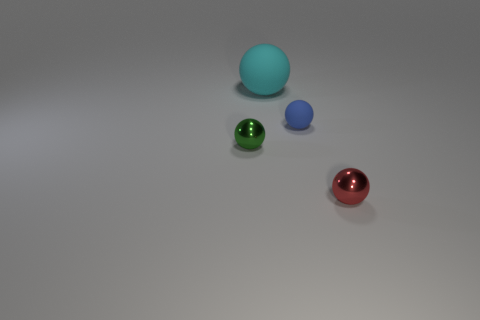Subtract all blue spheres. How many spheres are left? 3 Subtract all tiny red metal spheres. How many spheres are left? 3 Subtract all gray balls. Subtract all red cubes. How many balls are left? 4 Add 1 green shiny spheres. How many objects exist? 5 Subtract all red objects. Subtract all shiny spheres. How many objects are left? 1 Add 4 tiny red shiny balls. How many tiny red shiny balls are left? 5 Add 4 cyan balls. How many cyan balls exist? 5 Subtract 0 brown cubes. How many objects are left? 4 